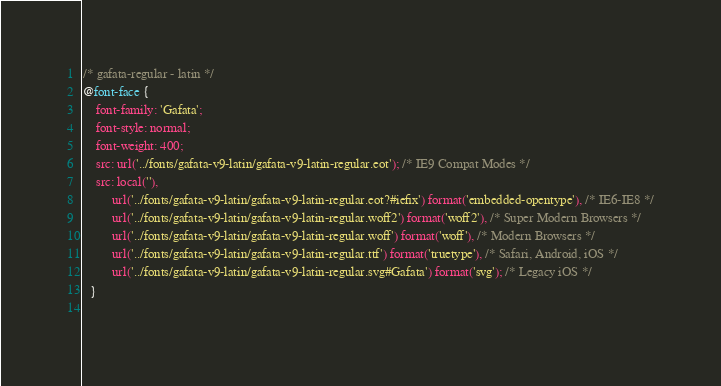<code> <loc_0><loc_0><loc_500><loc_500><_CSS_>/* gafata-regular - latin */
@font-face {
    font-family: 'Gafata';
    font-style: normal;
    font-weight: 400;
    src: url('../fonts/gafata-v9-latin/gafata-v9-latin-regular.eot'); /* IE9 Compat Modes */
    src: local(''),
         url('../fonts/gafata-v9-latin/gafata-v9-latin-regular.eot?#iefix') format('embedded-opentype'), /* IE6-IE8 */
         url('../fonts/gafata-v9-latin/gafata-v9-latin-regular.woff2') format('woff2'), /* Super Modern Browsers */
         url('../fonts/gafata-v9-latin/gafata-v9-latin-regular.woff') format('woff'), /* Modern Browsers */
         url('../fonts/gafata-v9-latin/gafata-v9-latin-regular.ttf') format('truetype'), /* Safari, Android, iOS */
         url('../fonts/gafata-v9-latin/gafata-v9-latin-regular.svg#Gafata') format('svg'); /* Legacy iOS */
  }
  </code> 